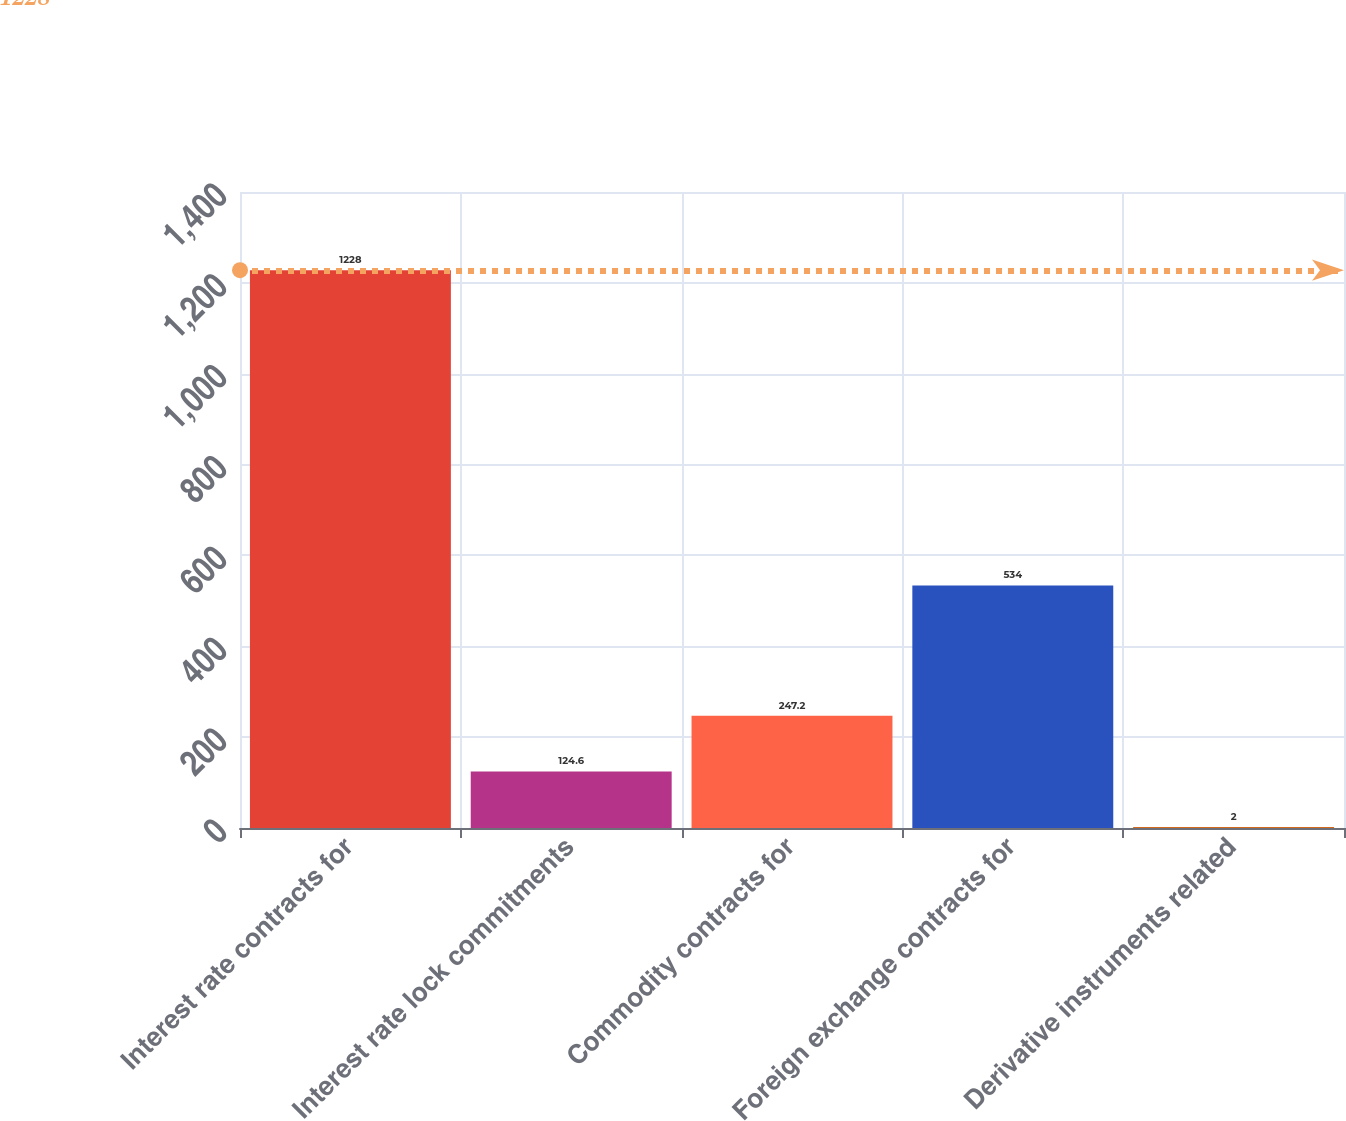<chart> <loc_0><loc_0><loc_500><loc_500><bar_chart><fcel>Interest rate contracts for<fcel>Interest rate lock commitments<fcel>Commodity contracts for<fcel>Foreign exchange contracts for<fcel>Derivative instruments related<nl><fcel>1228<fcel>124.6<fcel>247.2<fcel>534<fcel>2<nl></chart> 